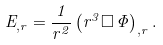<formula> <loc_0><loc_0><loc_500><loc_500>E _ { , r } = \frac { 1 } { r ^ { 2 } } \left ( r ^ { 3 } \Box \, \Phi \right ) _ { , r } .</formula> 